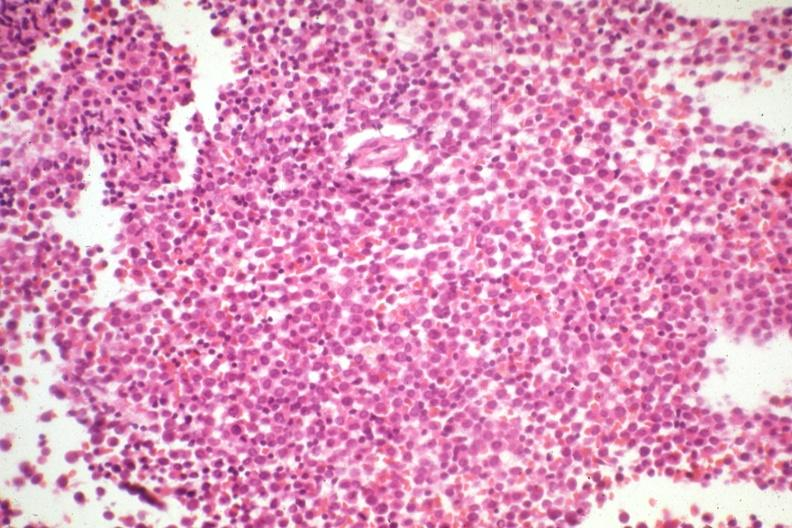s acute myelogenous leukemia present?
Answer the question using a single word or phrase. Yes 